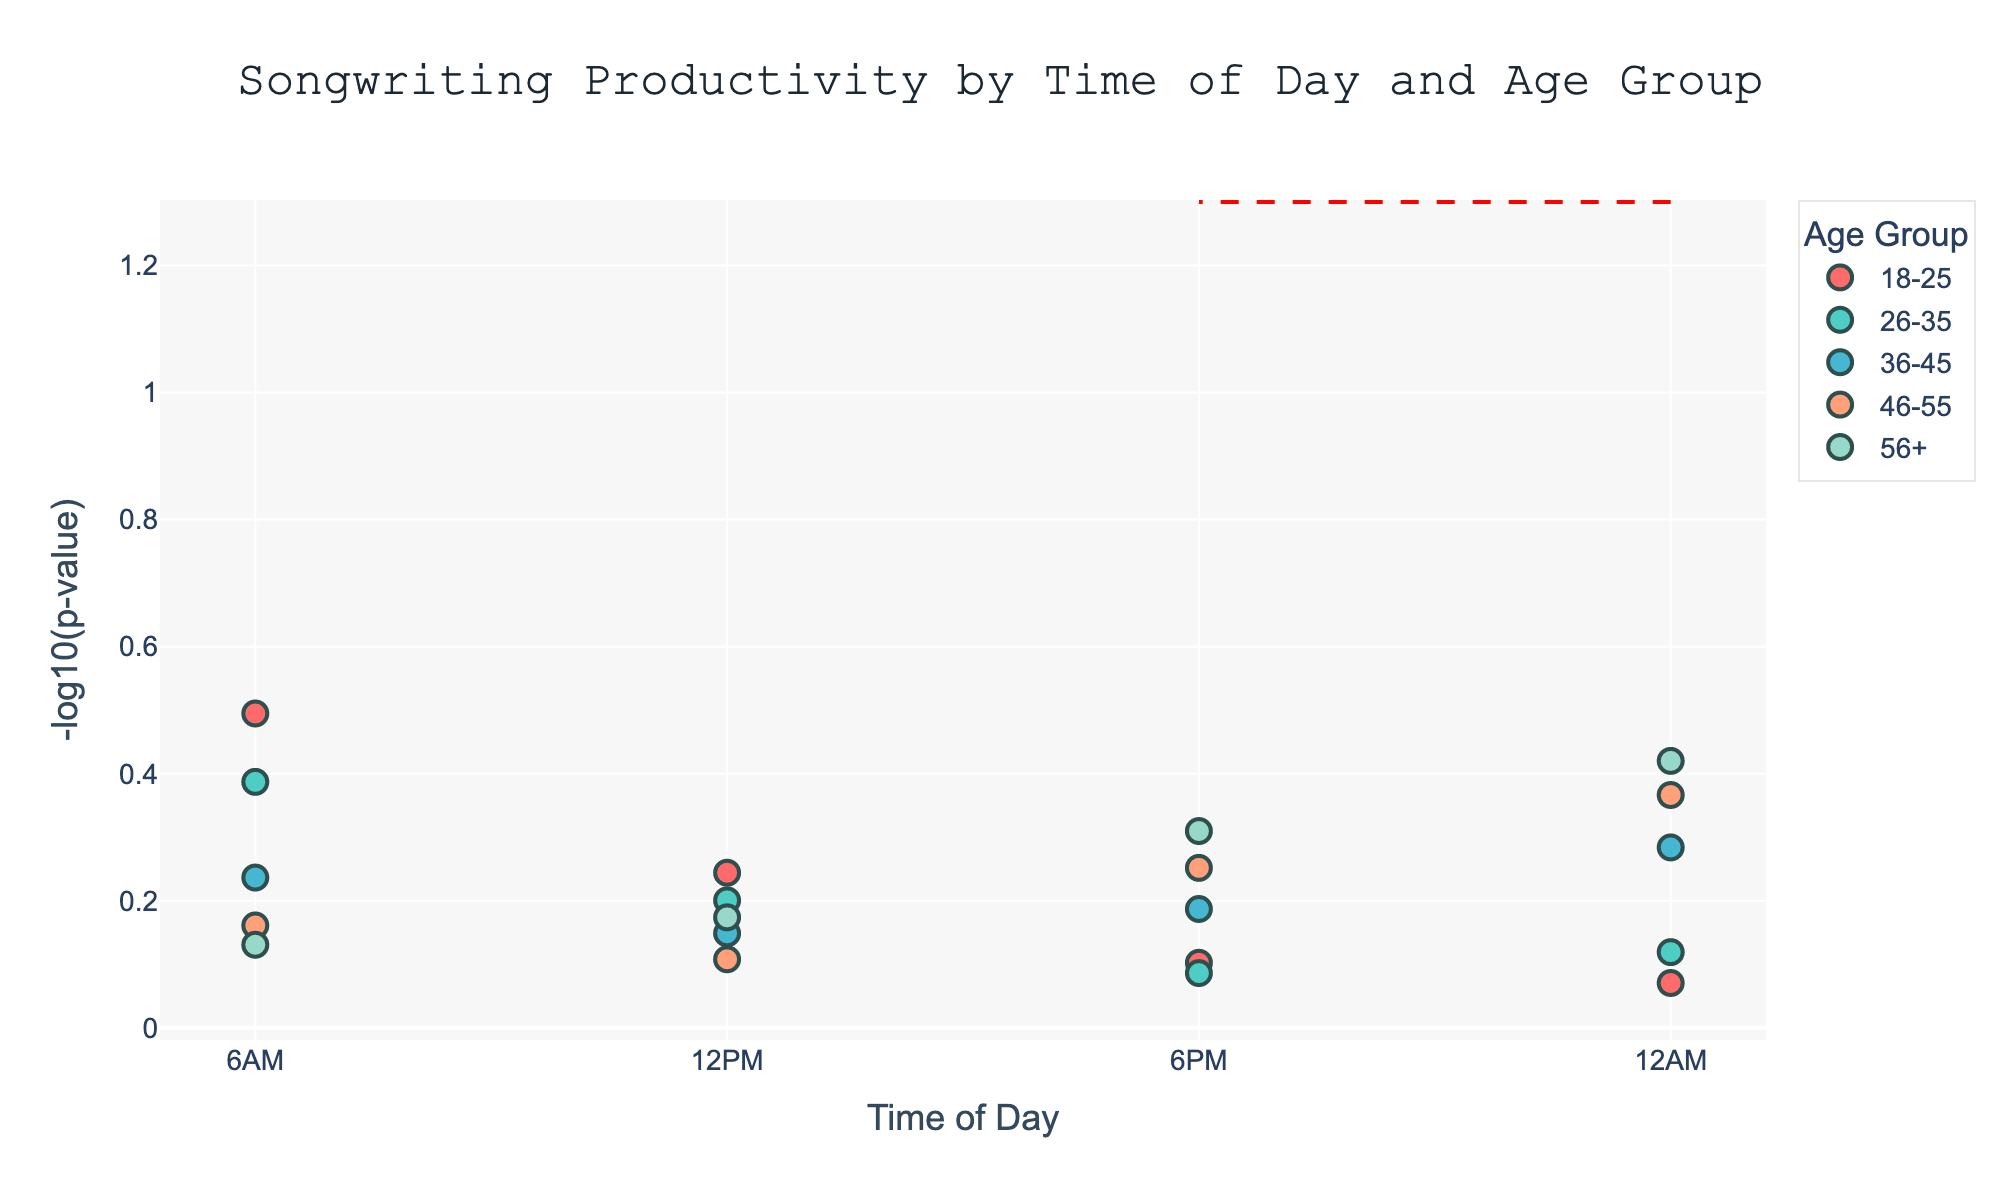What's the title of the Manhattan Plot? The title of the plot is usually displayed at the top. By looking there, we can find the title, which is "Songwriting Productivity by Time of Day and Age Group".
Answer: Songwriting Productivity by Time of Day and Age Group At what time of day do the 18-25 age group reach their peak productivity? Look at the markers for the 18-25 age group across different times of day and identify the highest point on the y-axis. The highest marker appears at 12AM.
Answer: 12AM How does the productivity of the 26-35 age group at 12PM compare with their productivity at 12AM? Examining the markers for the 26-35 age group, find the y-values (Negative_Log_P) for both 12PM and 12AM. The 12PM point is higher than the 12AM point, indicating higher productivity at 12PM.
Answer: Higher at 12PM Which age group shows the highest productivity at 6AM? Compare all the markers along the 6AM x-axis point across different age groups and identify the one with the highest y-value. The 56+ age group has the highest marker at 6AM.
Answer: 56+ What is the productivity pattern for the 36-45 age group throughout the day? Track the markers of the 36-45 age group across various times of the day. The highest productivity is at 12PM, followed by a decrease at 6PM and 12AM, while 6AM is the second least productive.
Answer: Peaks at 12PM, then decreases At which time of day do the musicians in the 46-55 age group have their lowest productivity? Locate the lowest marker for the 46-55 age group across the different time points. The lowest productivity for this group occurs at 12AM.
Answer: 12AM Compare the evening (6PM) productivity across all age groups. Which age group is the least productive? Looking at the 6PM markers for all age groups, identify the one with the lowest y-value. It's the 56+ age group that has the lowest y-value at 6PM.
Answer: 56+ Is there any age group whose productivity decreases consistently from morning to night? Follow the markers for each age group from 6AM to 12AM. The 56+ age group shows a consistent decrease from 6AM to 12AM.
Answer: 56+ How does the color coding help in differentiating between age groups? Each age group is represented by a different color, making it easier to distinguish data points related to different age groups at different times of the day. By referring to the legend, one can identify which color corresponds to which age group.
Answer: By distinct colors in legend What does the red horizontal line signify in the plot? The red horizontal line generally represents a significance threshold in a Manhattan Plot, below which the p-values (indicated as -log10(p-value)) are not considered significant. In this plot, it might be indicating that productivity scores below the level of 1.3 on the y-axis are not considered significant.
Answer: Significance threshold 